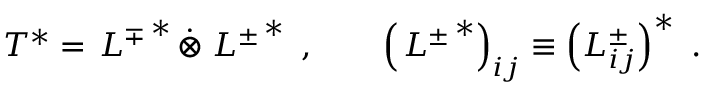Convert formula to latex. <formula><loc_0><loc_0><loc_500><loc_500>T ^ { * } = L ^ { \mp } ^ { * } \dot { \otimes } L ^ { \pm } ^ { * } , \left ( L ^ { \pm } ^ { * } \right ) _ { i j } \equiv \left ( L _ { i j } ^ { \pm } \right ) ^ { * } .</formula> 